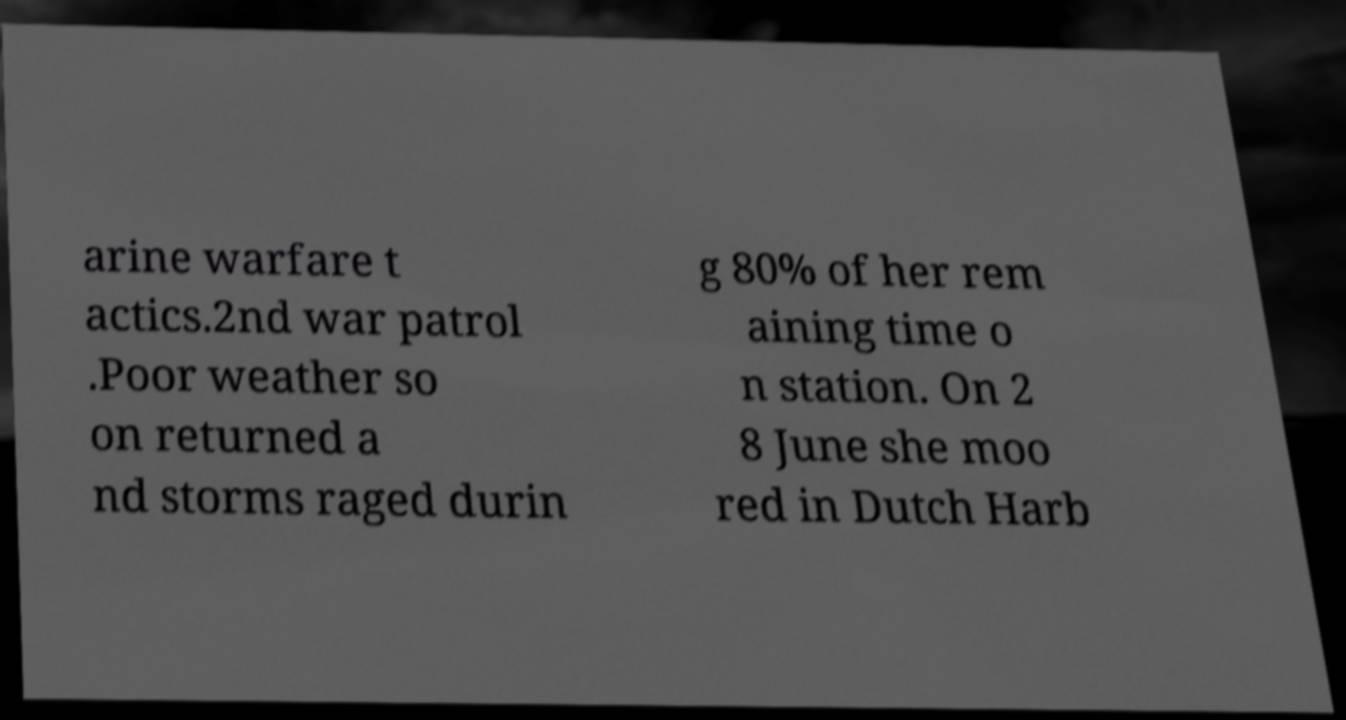Please read and relay the text visible in this image. What does it say? arine warfare t actics.2nd war patrol .Poor weather so on returned a nd storms raged durin g 80% of her rem aining time o n station. On 2 8 June she moo red in Dutch Harb 